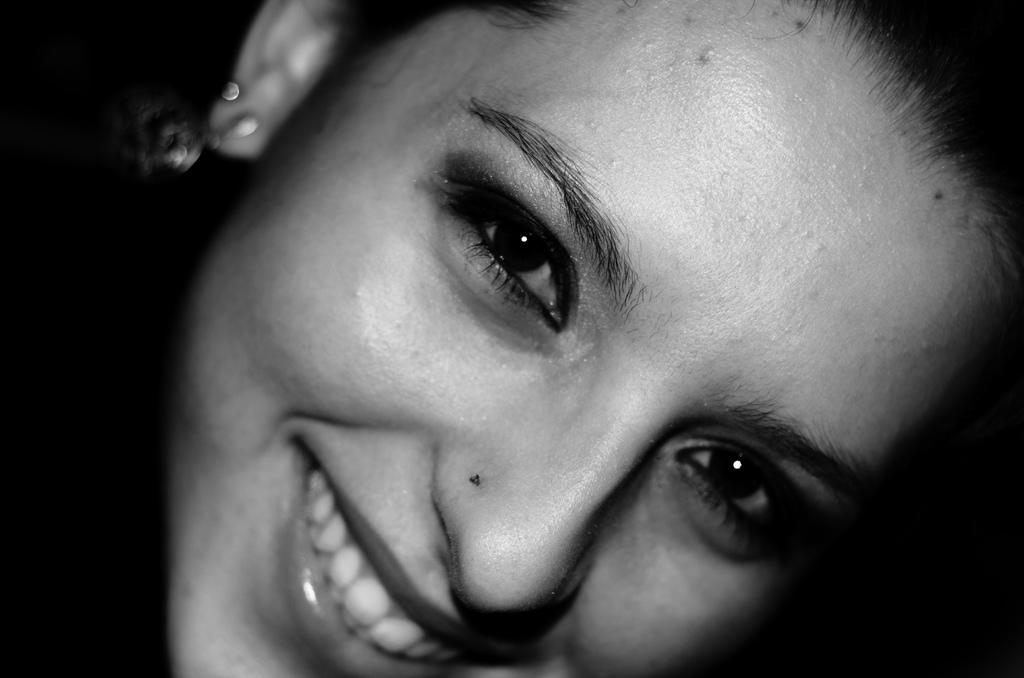What is the main subject of the image? There is a person's face in the image. What expression does the person have? The person is smiling. What color is the background of the image? The background of the image is black. How many rabbits can be seen in the image? There are no rabbits present in the image. What type of bulb is illuminating the person's face in the image? There is no bulb present in the image; the background is black. 